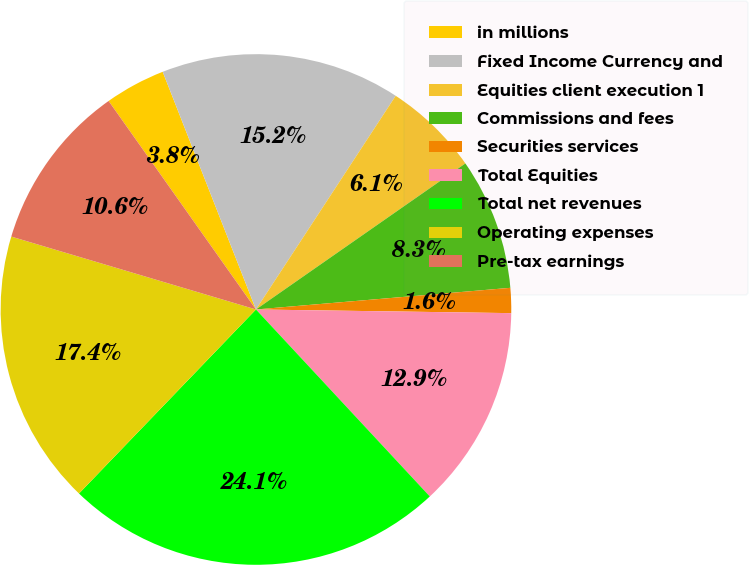<chart> <loc_0><loc_0><loc_500><loc_500><pie_chart><fcel>in millions<fcel>Fixed Income Currency and<fcel>Equities client execution 1<fcel>Commissions and fees<fcel>Securities services<fcel>Total Equities<fcel>Total net revenues<fcel>Operating expenses<fcel>Pre-tax earnings<nl><fcel>3.84%<fcel>15.17%<fcel>6.09%<fcel>8.34%<fcel>1.58%<fcel>12.85%<fcel>24.11%<fcel>17.42%<fcel>10.6%<nl></chart> 